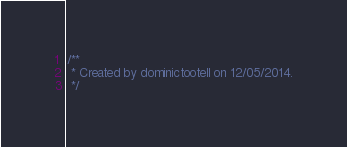<code> <loc_0><loc_0><loc_500><loc_500><_Java_>/**
 * Created by dominictootell on 12/05/2014.
 */</code> 